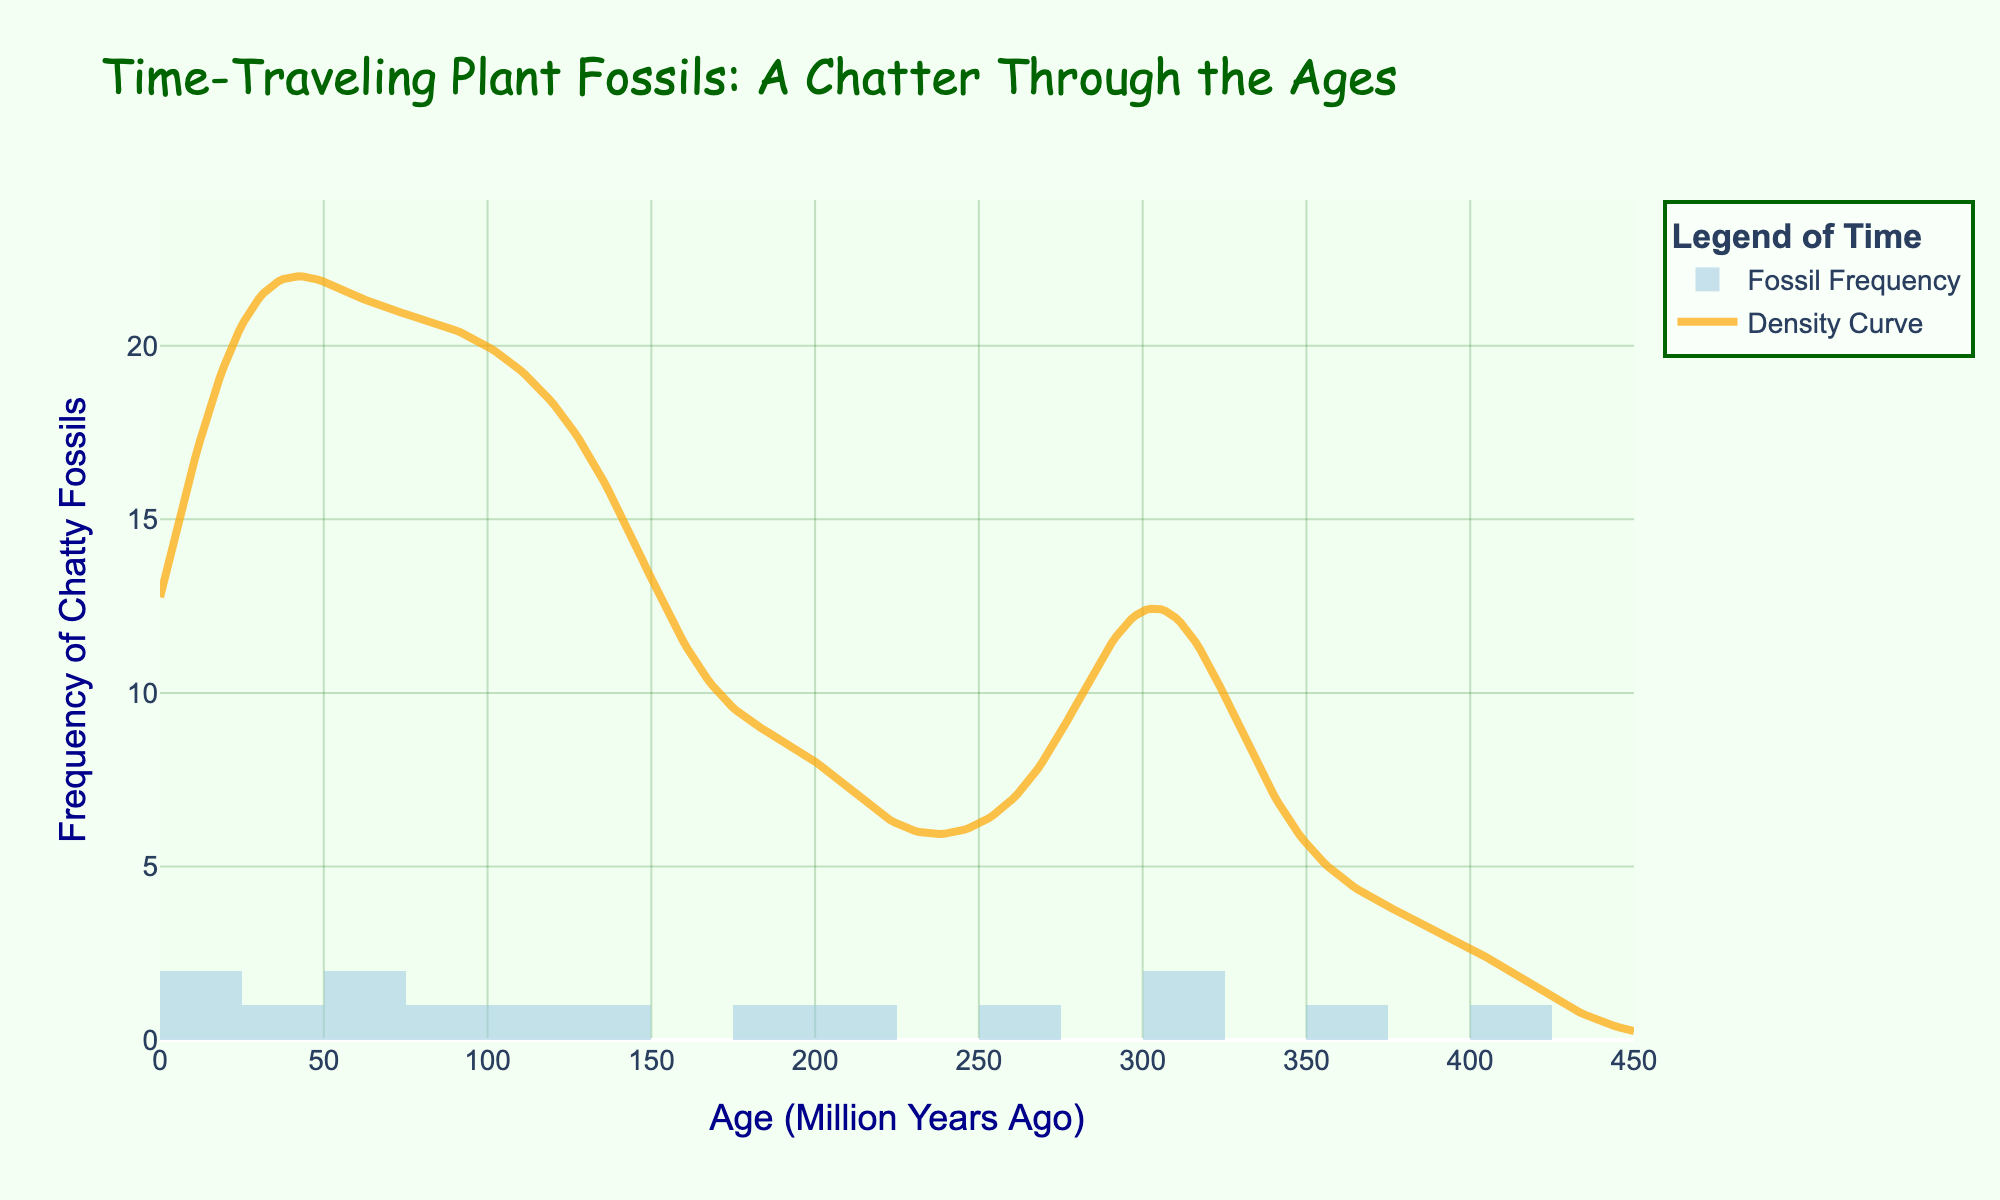What is the title of the plot? The title is situated at the top of the plot and reads "Time-Traveling Plant Fossils: A Chatter Through the Ages".
Answer: Time-Traveling Plant Fossils: A Chatter Through the Ages What is the age range of fossilized plant data shown in the histogram? The age range can be determined by examining the x-axis, which is labeled with values from 0 to 450 million years.
Answer: 0 to 450 million years Which fossil plant had the highest frequency in the dataset? By looking at the height of the bars, the tallest bar corresponds to the Cretaceous Flowering Plant, with a frequency of 22.
Answer: Cretaceous Flowering Plant How does the density curve change around the age of 120 million years? Observing the density curve, it reaches a peak around 120 million years, indicating a higher density of fossil frequencies in this period.
Answer: Peak around 120 million years What is the frequency of the Triassic Conifer? According to the histogram, the bar for the Triassic Conifer, which is noted at 200 million years, has a height corresponding to a frequency of 11.
Answer: 11 Comparing the Jurassic Fern and Paleozoic Palm, which has a higher frequency and by how much? The Jurassic Fern has a frequency of 18, while the Paleozoic Palm has a frequency of 8, making the Jurassic Fern higher by 10.
Answer: Jurassic Fern by 10 What time period has the lowest density of plant fossil frequencies according to the KDE curve? Observing the KDE curve, the lowest density occurs at the far ends of the age range, particularly near the very young (2 million years) and the very old (400 million years) periods.
Answer: Near 400 million years Between 55 and 90 million years ago, which plant fossil had the higher frequency, Paleocene Palm or Cretaceous Flowering Plant? Referring to the histogram, the Cretaceous Flowering Plant (90 million years) has a frequency of 22, while the Paleocene Palm (55 million years) has a frequency of 8. Therefore, Cretaceous Flowering Plant has a higher frequency.
Answer: Cretaceous Flowering Plant How many distinct fossil plant ages are presented in the figure? Each bar in the histogram represents a distinct fossil plant age, and there are 14 bars in total.
Answer: 14 What is the sum of frequencies for all fossilized plants during the Mesozoic era (Triassic, Jurassic, Cretaceous)? Adding the frequencies: Triassic Conifer (11), Jurassic Fern (18) + Jurassic Ginkgo (15) + Jurassic Bennettite (5), Cretaceous Cycad (12) + Cretaceous Flowering Plant (22). The total is 11 + 38 + 34 = 83.
Answer: 83 